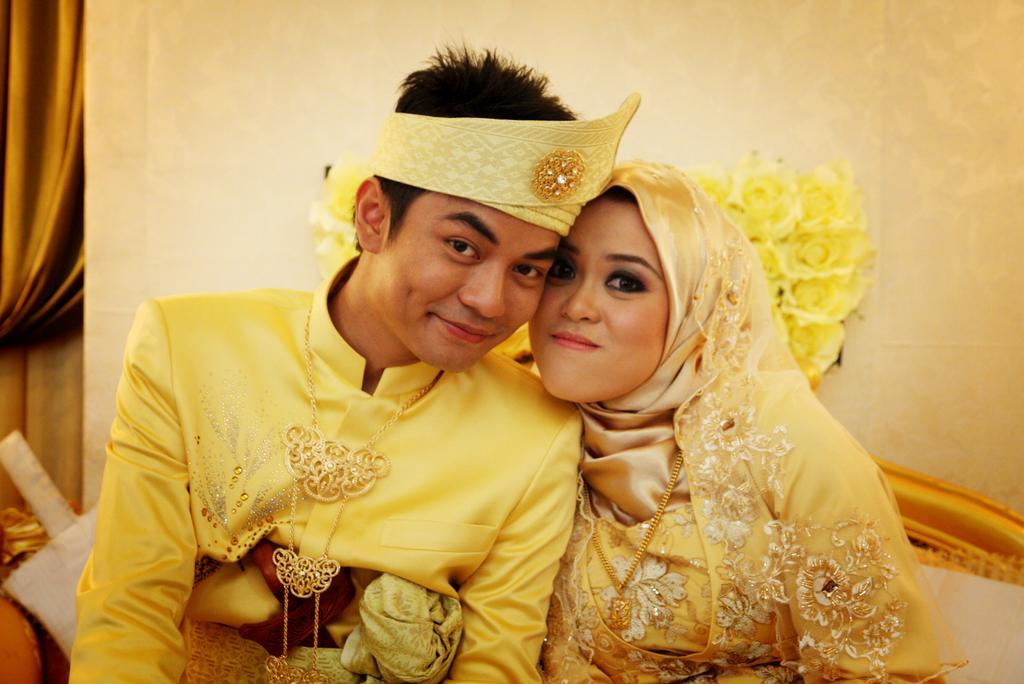Can you describe this image briefly? In this image we can see a couple who are wearing similar color dress, male person also wearing headband sitting together and hugging and in the background of the image there is a wall, there are some flower bouquets and a curtain. 